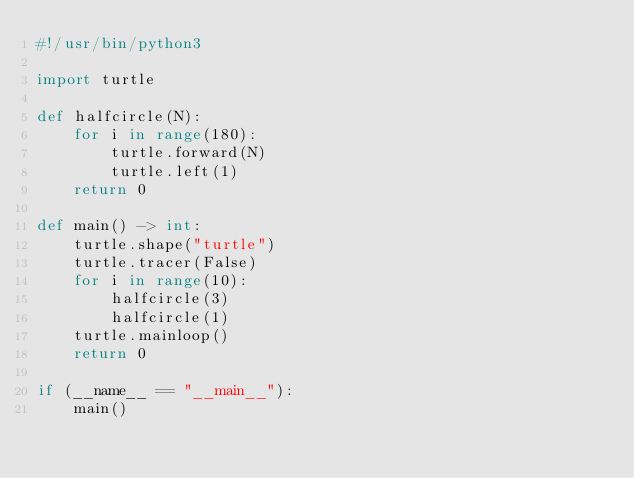Convert code to text. <code><loc_0><loc_0><loc_500><loc_500><_Python_>#!/usr/bin/python3

import turtle

def halfcircle(N):
    for i in range(180):
        turtle.forward(N)
        turtle.left(1)
    return 0

def main() -> int:
    turtle.shape("turtle")
    turtle.tracer(False)
    for i in range(10):
        halfcircle(3)
        halfcircle(1)
    turtle.mainloop()
    return 0

if (__name__ == "__main__"):
    main()
</code> 